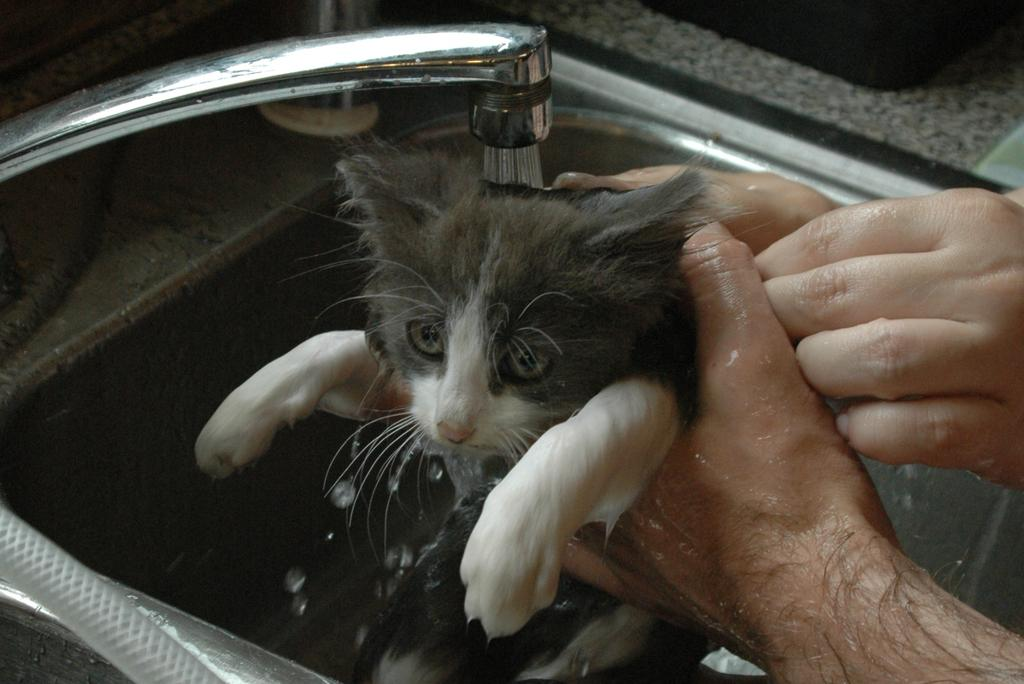What is the main activity taking place in the image? There is a person in the image who is cleaning a cat. What is being used to clean the cat? Water is being used for cleaning, and it is coming from a tap. Where is the cleaning taking place? The cleaning is taking place in a sink. How many bikes are parked next to the sink in the image? There are no bikes present in the image; the cleaning is taking place in a sink with a person cleaning a cat. Can you see a hen in the image? There is no hen present in the image; the focus is on the person cleaning the cat in a sink. 